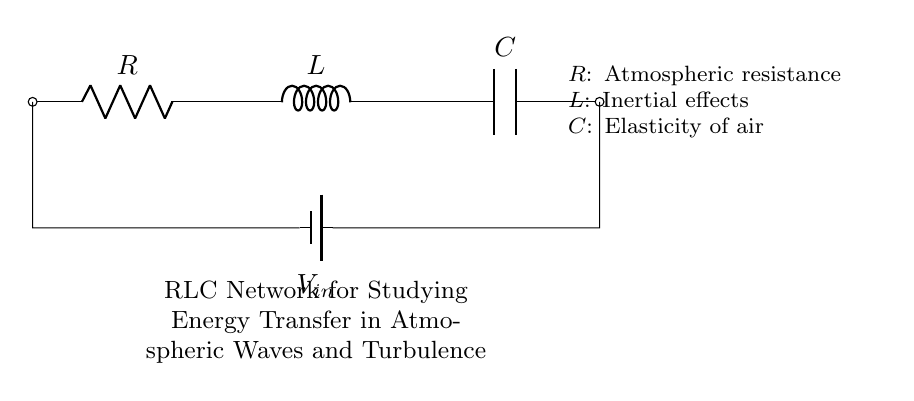What components are present in the circuit? The circuit includes a resistor, an inductor, and a capacitor, which are the basic components that form the RLC network.
Answer: Resistor, inductor, capacitor What does the symbol $V_{in}$ represent? The symbol $V_{in}$ denotes the input voltage source that supplies energy to the RLC network, influencing the behavior of the circuit.
Answer: Input voltage What is the role of resistance in this circuit? Resistance opposes the flow of electrical current within the circuit, affecting how energy is dissipated as heat, which is analogous to atmospheric resistance influencing energy transfer in waves.
Answer: Opposes current flow How do the components affect energy transfer in atmospheric waves? The resistor, inductor, and capacitor together regulate the energy transfer; the resistor dissipates energy, the inductor stores energy in a magnetic field, and the capacitor stores energy in an electric field, simulating interactions in atmospheric turbulence.
Answer: Regulate energy transfer What is the impact of the inductor on the performance of the circuit? The inductor introduces inertial effects that delay changes in current, affecting the circuit's response to fluctuations in the input voltage, which can model inertia in atmospheric dynamics as waves propagate.
Answer: Delays current changes 